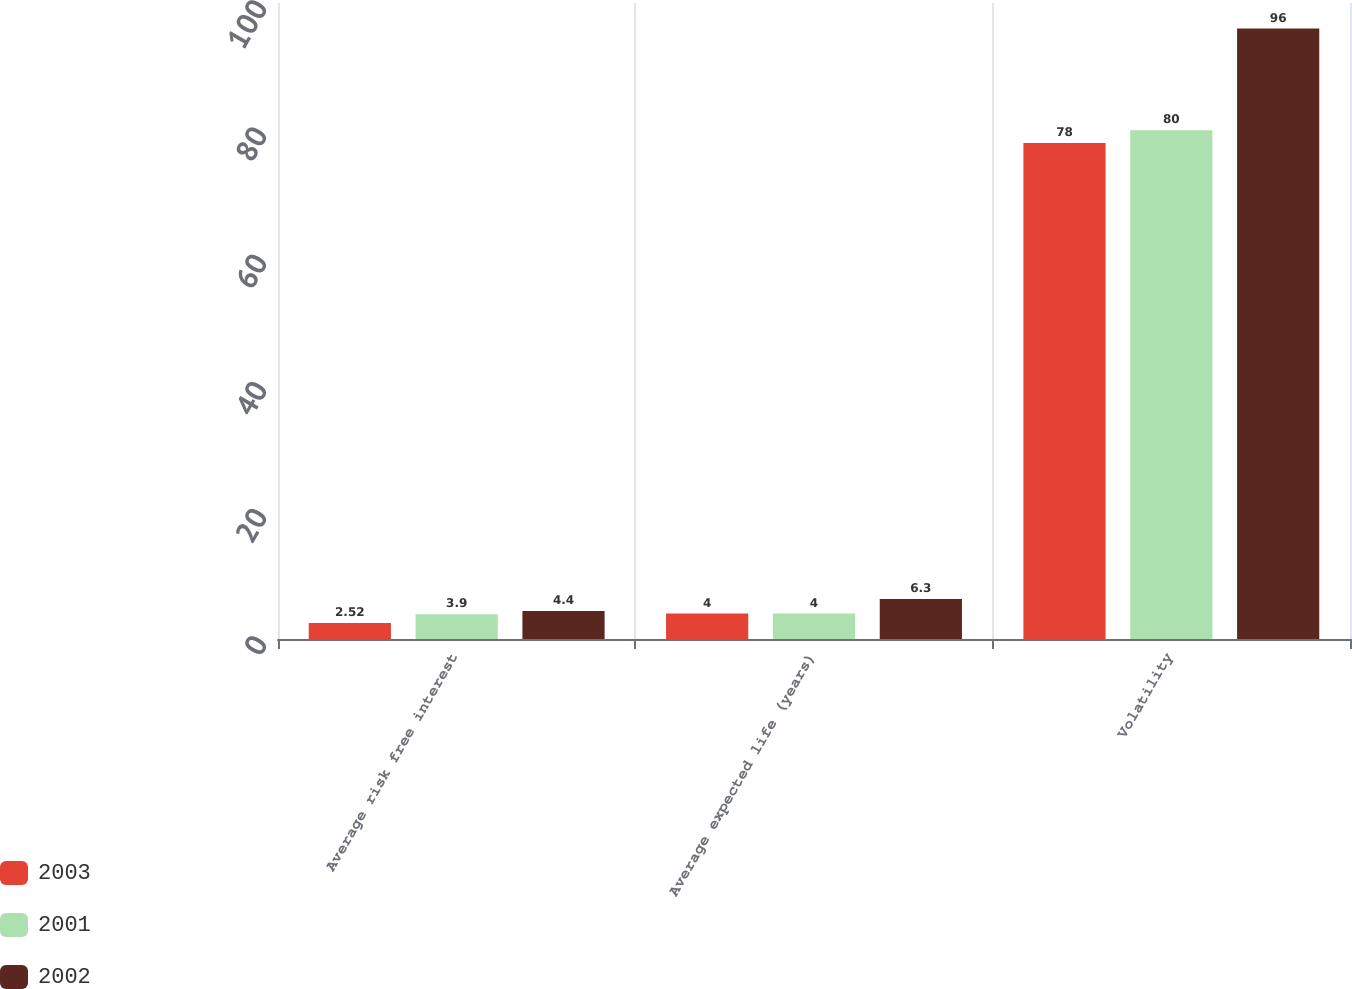Convert chart. <chart><loc_0><loc_0><loc_500><loc_500><stacked_bar_chart><ecel><fcel>Average risk free interest<fcel>Average expected life (years)<fcel>Volatility<nl><fcel>2003<fcel>2.52<fcel>4<fcel>78<nl><fcel>2001<fcel>3.9<fcel>4<fcel>80<nl><fcel>2002<fcel>4.4<fcel>6.3<fcel>96<nl></chart> 